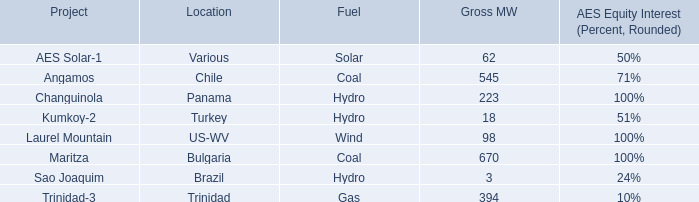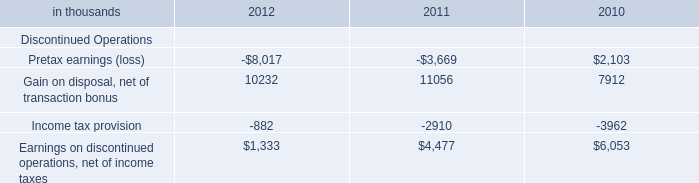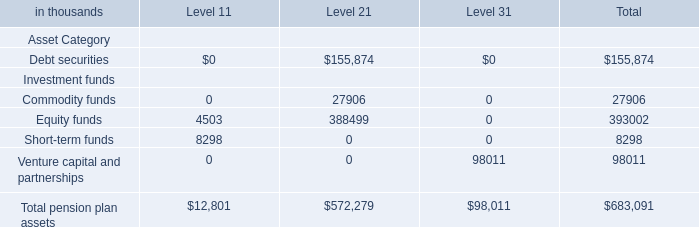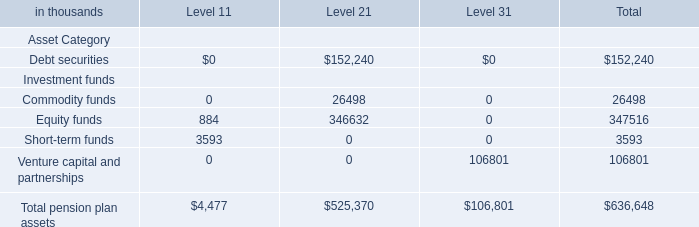What is the sum of Equity funds for Level 1 and Venture capital and partnerships for Level 3? (in thousand) 
Computations: (4503 + 106801)
Answer: 111304.0. 